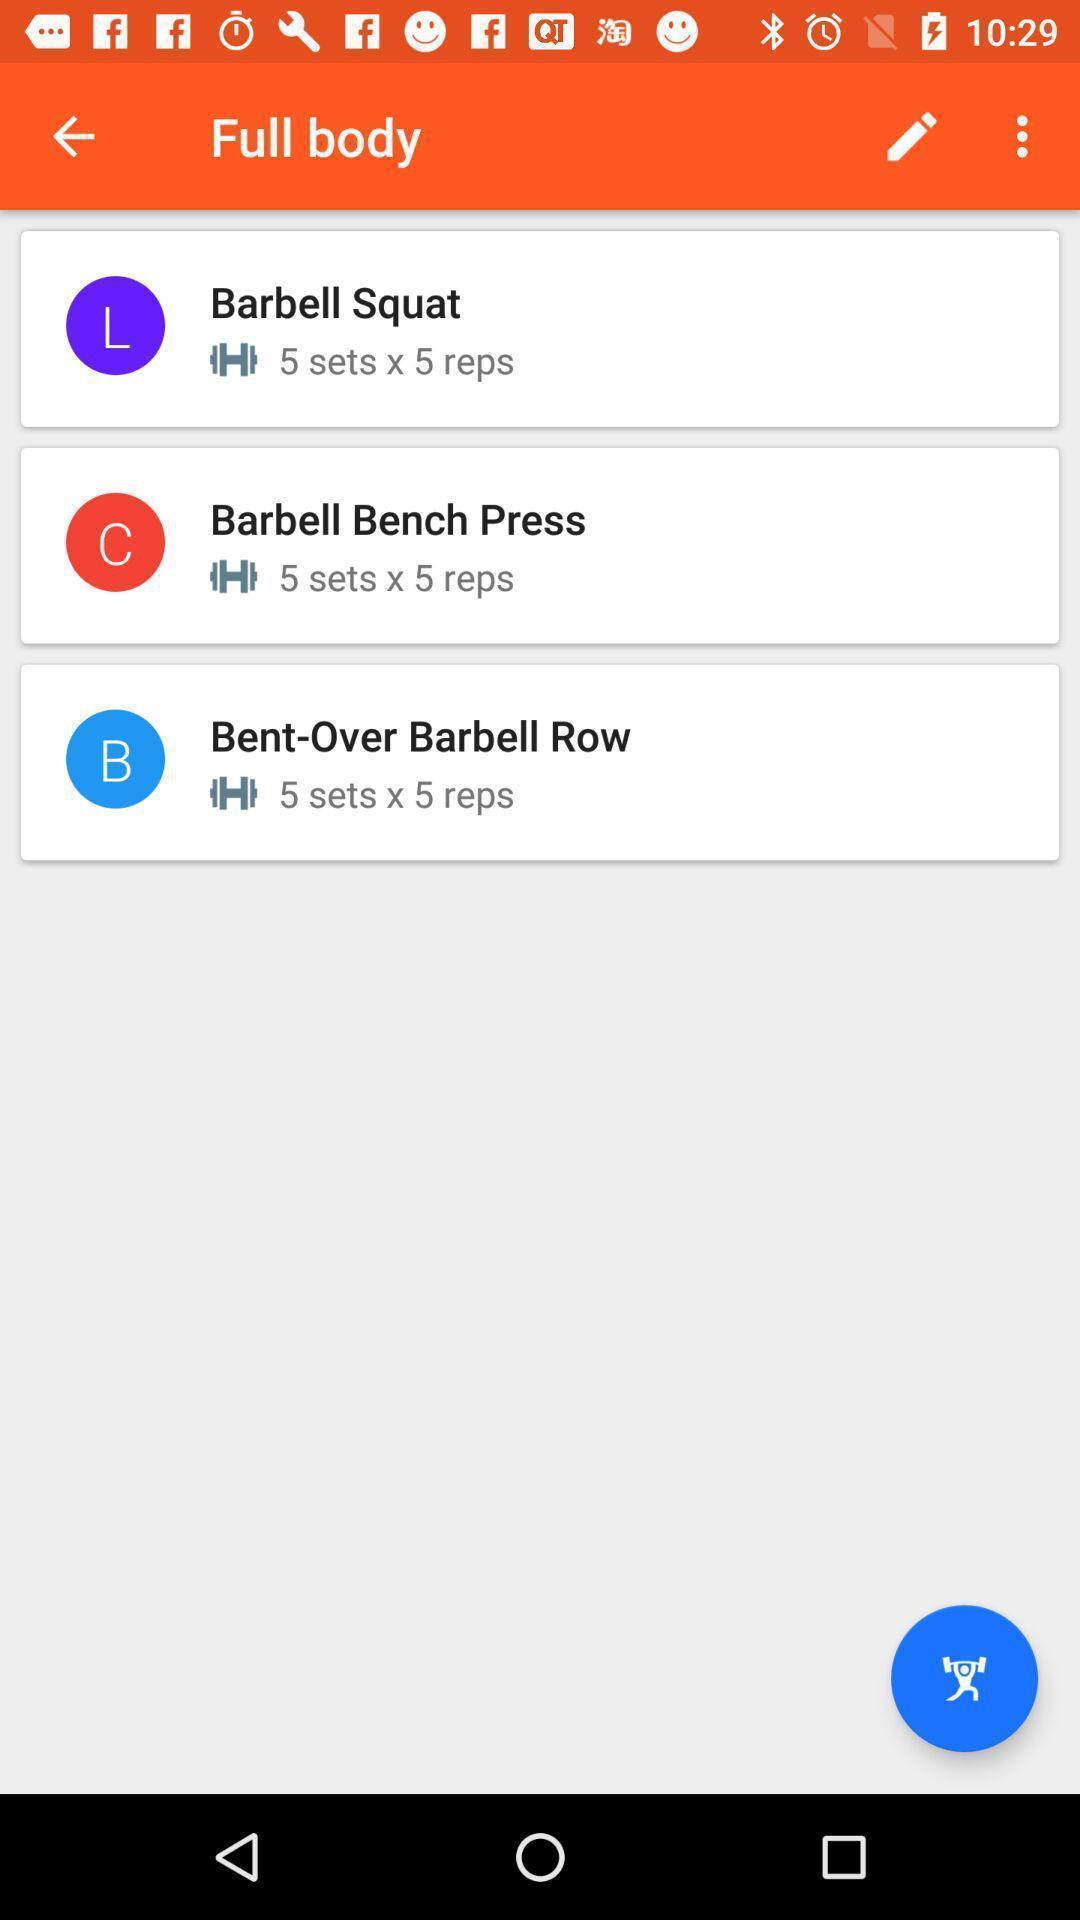Explain the elements present in this screenshot. Screen shows a page of workouts. 